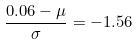Convert formula to latex. <formula><loc_0><loc_0><loc_500><loc_500>\frac { 0 . 0 6 - \mu } { \sigma } = - 1 . 5 6</formula> 